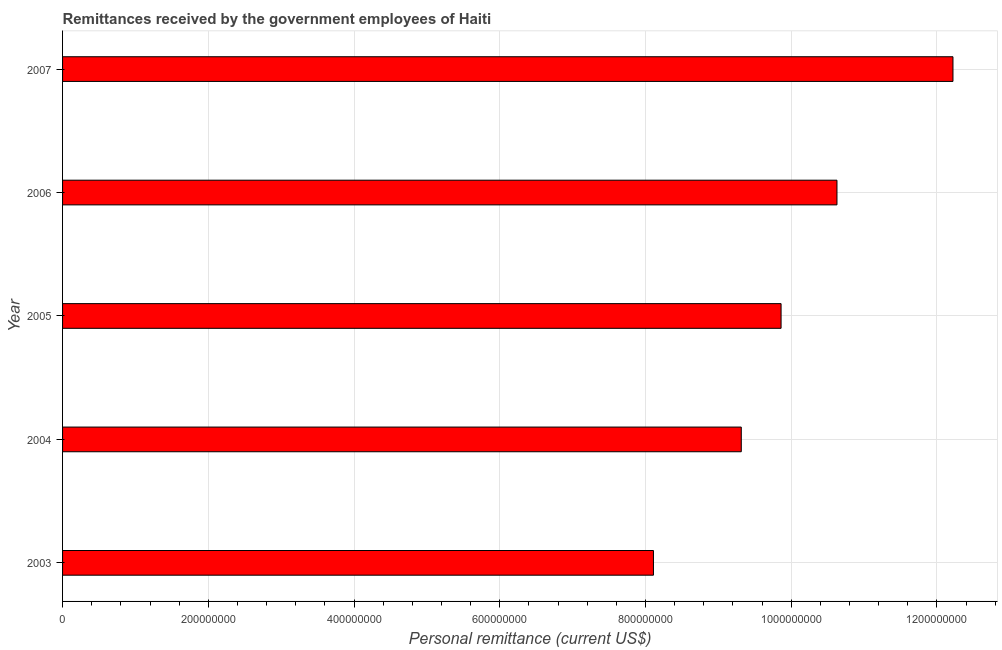Does the graph contain any zero values?
Make the answer very short. No. Does the graph contain grids?
Your answer should be very brief. Yes. What is the title of the graph?
Ensure brevity in your answer.  Remittances received by the government employees of Haiti. What is the label or title of the X-axis?
Your answer should be very brief. Personal remittance (current US$). What is the personal remittances in 2006?
Make the answer very short. 1.06e+09. Across all years, what is the maximum personal remittances?
Your response must be concise. 1.22e+09. Across all years, what is the minimum personal remittances?
Your answer should be compact. 8.11e+08. In which year was the personal remittances minimum?
Your response must be concise. 2003. What is the sum of the personal remittances?
Provide a succinct answer. 5.01e+09. What is the difference between the personal remittances in 2005 and 2007?
Make the answer very short. -2.36e+08. What is the average personal remittances per year?
Provide a succinct answer. 1.00e+09. What is the median personal remittances?
Give a very brief answer. 9.86e+08. What is the ratio of the personal remittances in 2003 to that in 2005?
Your answer should be very brief. 0.82. Is the personal remittances in 2005 less than that in 2007?
Offer a terse response. Yes. Is the difference between the personal remittances in 2006 and 2007 greater than the difference between any two years?
Provide a succinct answer. No. What is the difference between the highest and the second highest personal remittances?
Offer a very short reply. 1.59e+08. Is the sum of the personal remittances in 2004 and 2006 greater than the maximum personal remittances across all years?
Provide a succinct answer. Yes. What is the difference between the highest and the lowest personal remittances?
Ensure brevity in your answer.  4.11e+08. In how many years, is the personal remittances greater than the average personal remittances taken over all years?
Provide a short and direct response. 2. What is the difference between two consecutive major ticks on the X-axis?
Your answer should be very brief. 2.00e+08. What is the Personal remittance (current US$) of 2003?
Offer a very short reply. 8.11e+08. What is the Personal remittance (current US$) of 2004?
Ensure brevity in your answer.  9.32e+08. What is the Personal remittance (current US$) in 2005?
Your answer should be very brief. 9.86e+08. What is the Personal remittance (current US$) of 2006?
Your answer should be compact. 1.06e+09. What is the Personal remittance (current US$) in 2007?
Offer a terse response. 1.22e+09. What is the difference between the Personal remittance (current US$) in 2003 and 2004?
Keep it short and to the point. -1.21e+08. What is the difference between the Personal remittance (current US$) in 2003 and 2005?
Keep it short and to the point. -1.75e+08. What is the difference between the Personal remittance (current US$) in 2003 and 2006?
Make the answer very short. -2.52e+08. What is the difference between the Personal remittance (current US$) in 2003 and 2007?
Provide a short and direct response. -4.11e+08. What is the difference between the Personal remittance (current US$) in 2004 and 2005?
Your answer should be compact. -5.46e+07. What is the difference between the Personal remittance (current US$) in 2004 and 2006?
Offer a very short reply. -1.31e+08. What is the difference between the Personal remittance (current US$) in 2004 and 2007?
Make the answer very short. -2.91e+08. What is the difference between the Personal remittance (current US$) in 2005 and 2006?
Your answer should be compact. -7.67e+07. What is the difference between the Personal remittance (current US$) in 2005 and 2007?
Give a very brief answer. -2.36e+08. What is the difference between the Personal remittance (current US$) in 2006 and 2007?
Your answer should be compact. -1.59e+08. What is the ratio of the Personal remittance (current US$) in 2003 to that in 2004?
Give a very brief answer. 0.87. What is the ratio of the Personal remittance (current US$) in 2003 to that in 2005?
Offer a very short reply. 0.82. What is the ratio of the Personal remittance (current US$) in 2003 to that in 2006?
Offer a very short reply. 0.76. What is the ratio of the Personal remittance (current US$) in 2003 to that in 2007?
Offer a very short reply. 0.66. What is the ratio of the Personal remittance (current US$) in 2004 to that in 2005?
Provide a succinct answer. 0.94. What is the ratio of the Personal remittance (current US$) in 2004 to that in 2006?
Your answer should be very brief. 0.88. What is the ratio of the Personal remittance (current US$) in 2004 to that in 2007?
Offer a very short reply. 0.76. What is the ratio of the Personal remittance (current US$) in 2005 to that in 2006?
Give a very brief answer. 0.93. What is the ratio of the Personal remittance (current US$) in 2005 to that in 2007?
Keep it short and to the point. 0.81. What is the ratio of the Personal remittance (current US$) in 2006 to that in 2007?
Your answer should be compact. 0.87. 